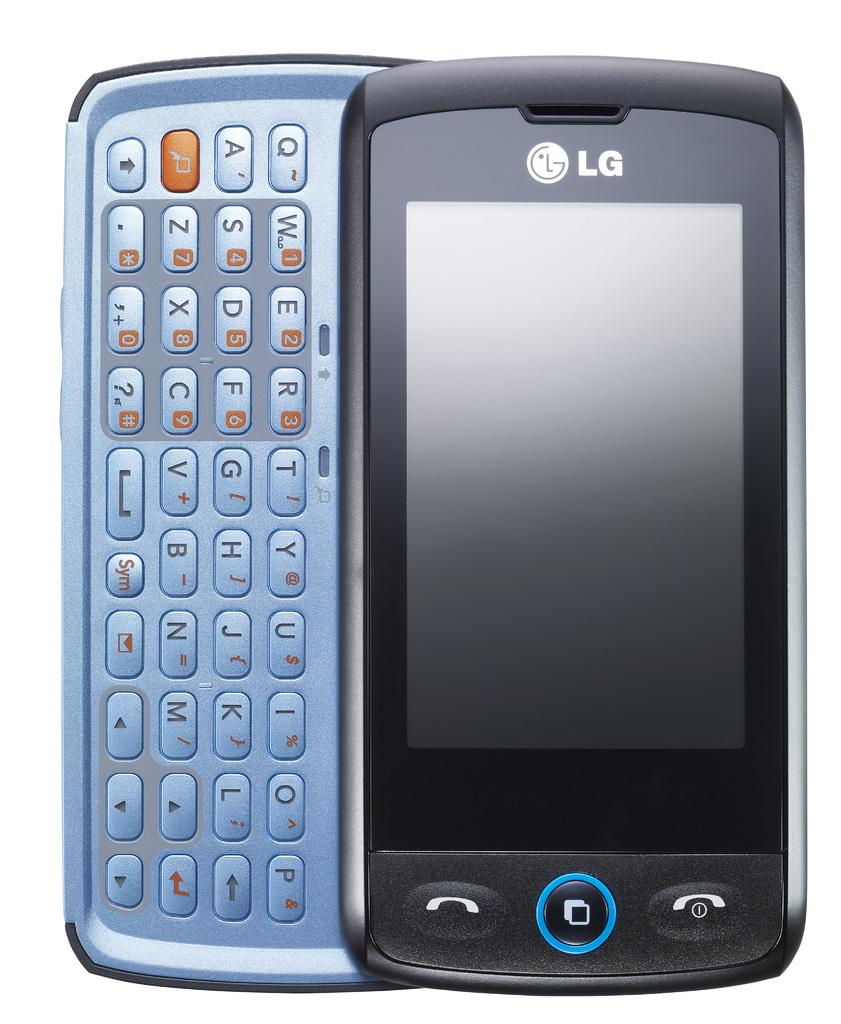<image>
Create a compact narrative representing the image presented. An LG cell phone with the keyboard slid out. 